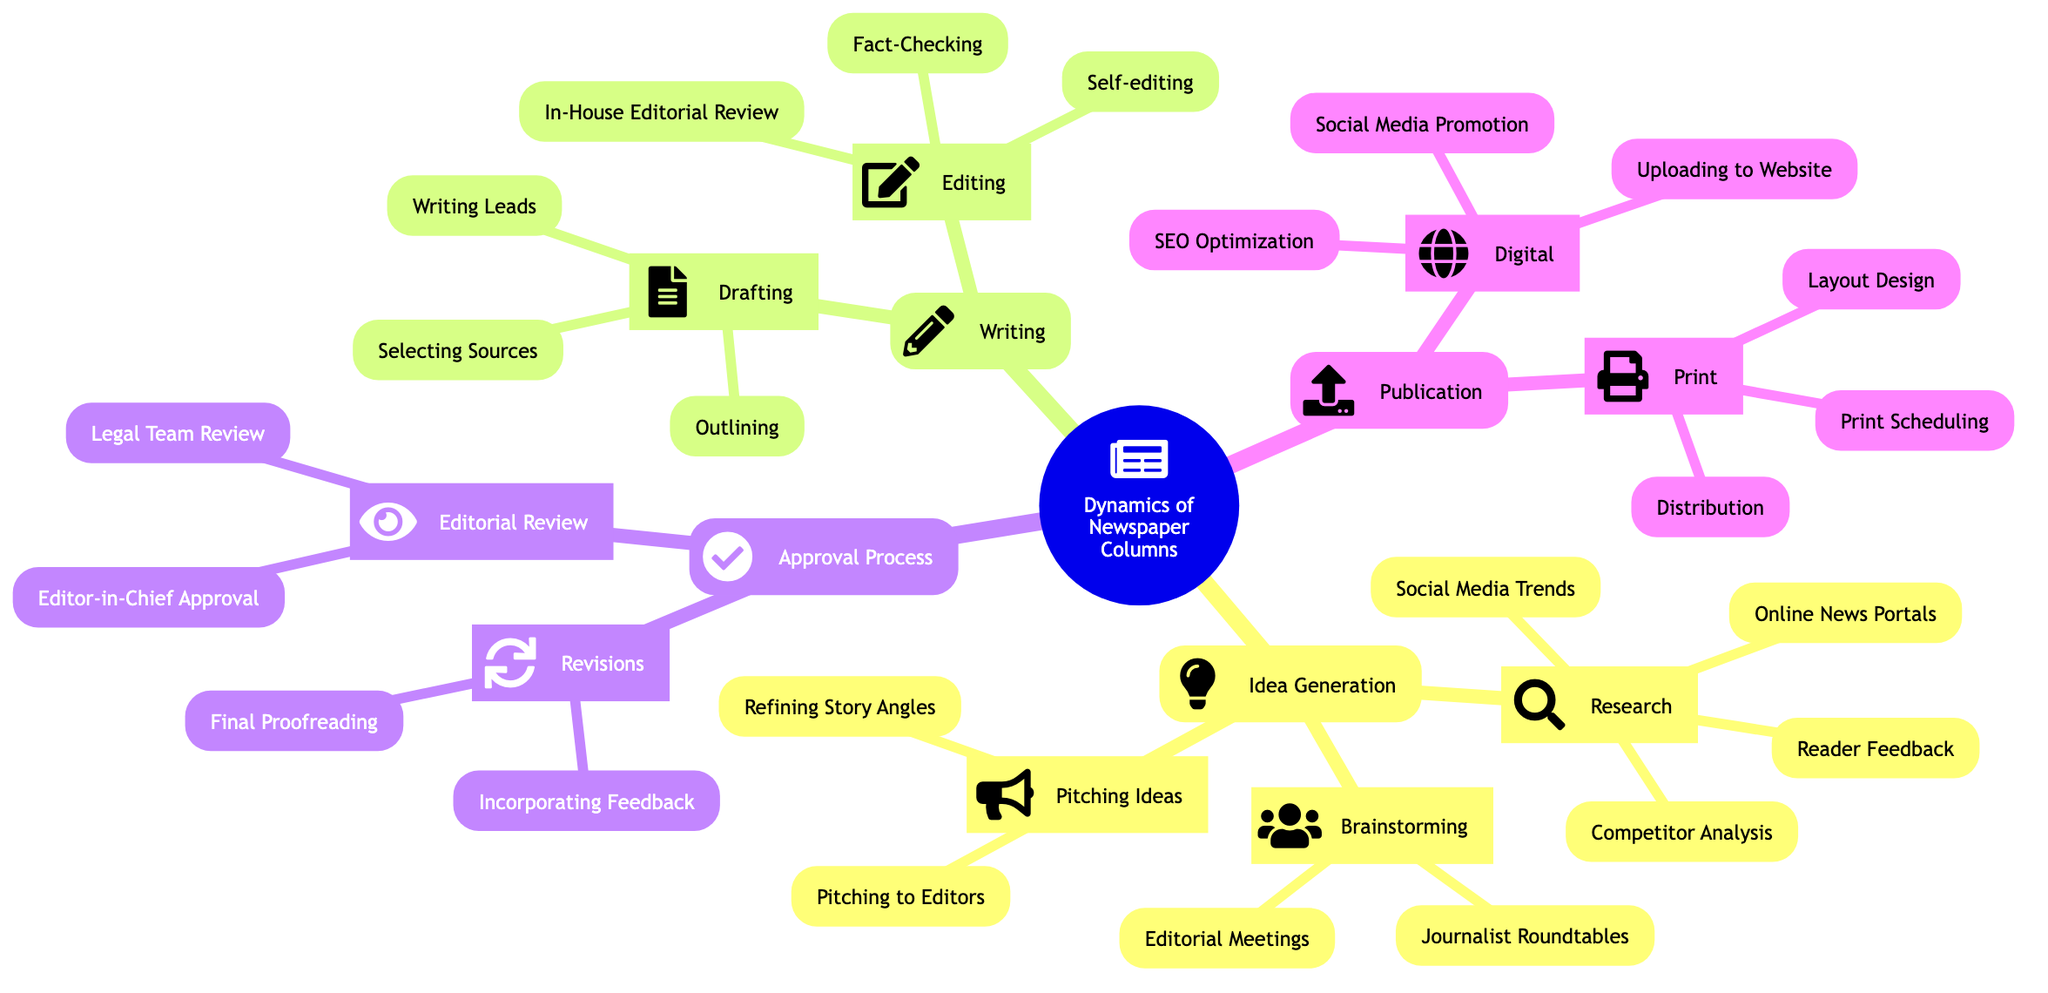What are the two main components of "Writing"? The "Writing" category includes "Drafting" and "Editing" as its two main components. This information is directly visible in the diagram under the "Writing" section, where both categories are listed.
Answer: Drafting, Editing How many research methods are listed under "Idea Generation"? In the diagram under "Idea Generation," there are four methods of research listed: Online News Portals, Competitor Analysis, Social Media Trends, and Reader Feedback. Counting these gives us the number four.
Answer: 4 Which step involves incorporating feedback? The process involving the incorporation of feedback occurs in the "Revisions" step under the "Approval Process." It is specified in the diagram that this is part of the feedback process during the approval stage.
Answer: Incorporating Feedback What is the final stage before publication? According to the diagram, the final stage before publication includes the activity of "Final Proofreading," which occurs in the "Revisions" section of the "Approval Process." This is the last check before an article is published.
Answer: Final Proofreading What is one activity listed under the "Publication" in print? Under the "Publication" section of the mind map, one of the activities listed for print is "Layout Design." This indicates what occurs during the publication phase specifically for print formats.
Answer: Layout Design How many parts does the "Approval Process" have? The "Approval Process" section is divided into two main parts as outlined in the diagram: "Editorial Review" and "Revisions." Counting these gives us two distinct components.
Answer: 2 Which component comes after "Drafting"? Following "Drafting" in the diagram is the "Editing" component, making it a sequential part of the writing process. The diagram clearly shows that after drafting, editing takes place.
Answer: Editing What kind of optimization is mentioned under "Digital" publication? The diagram indicates that "SEO Optimization" is part of the "Digital" publication process. This highlights an essential technique used to enhance online articles.
Answer: SEO Optimization 